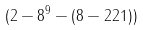<formula> <loc_0><loc_0><loc_500><loc_500>( 2 - 8 ^ { 9 } - ( 8 - 2 2 1 ) )</formula> 